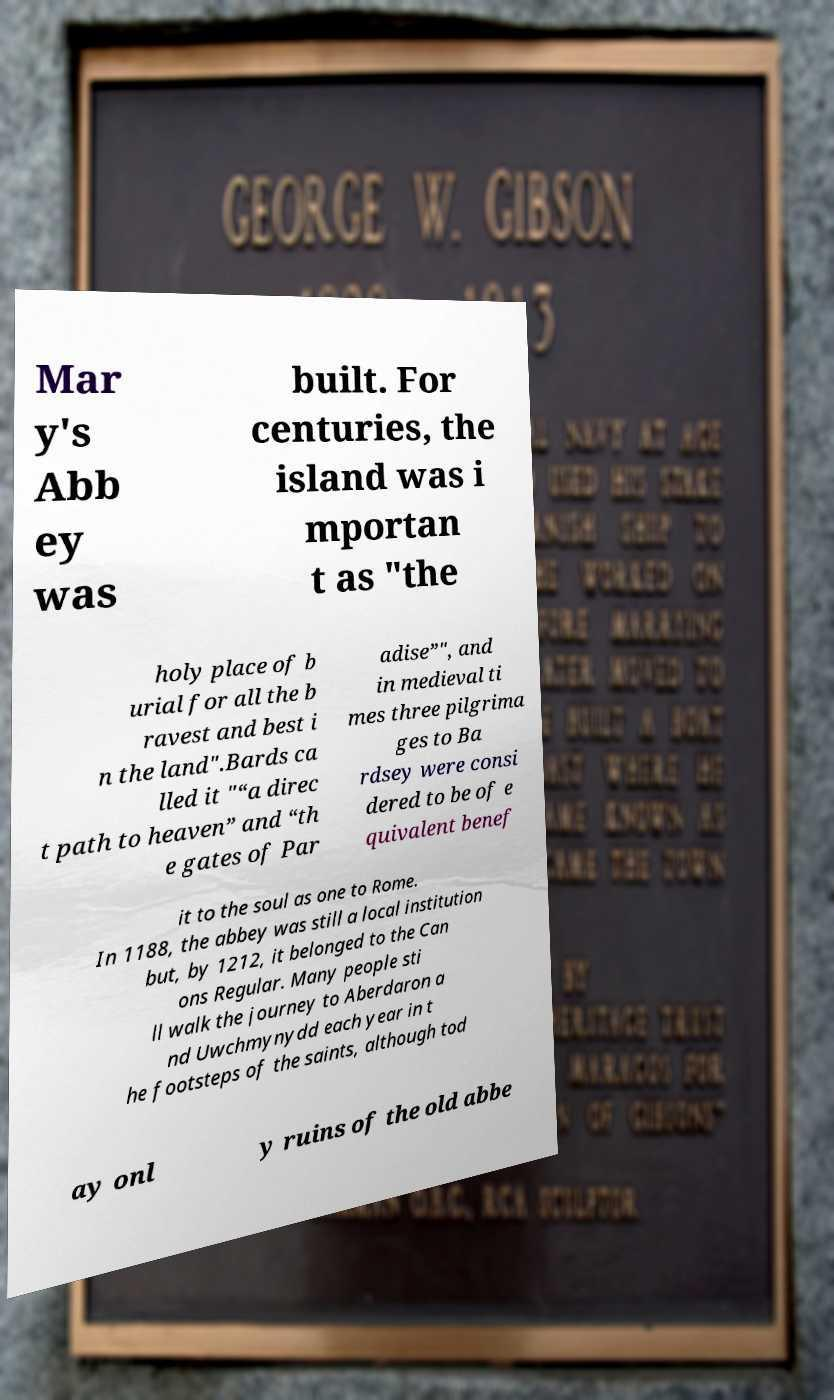Could you assist in decoding the text presented in this image and type it out clearly? Mar y's Abb ey was built. For centuries, the island was i mportan t as "the holy place of b urial for all the b ravest and best i n the land".Bards ca lled it "“a direc t path to heaven” and “th e gates of Par adise”", and in medieval ti mes three pilgrima ges to Ba rdsey were consi dered to be of e quivalent benef it to the soul as one to Rome. In 1188, the abbey was still a local institution but, by 1212, it belonged to the Can ons Regular. Many people sti ll walk the journey to Aberdaron a nd Uwchmynydd each year in t he footsteps of the saints, although tod ay onl y ruins of the old abbe 